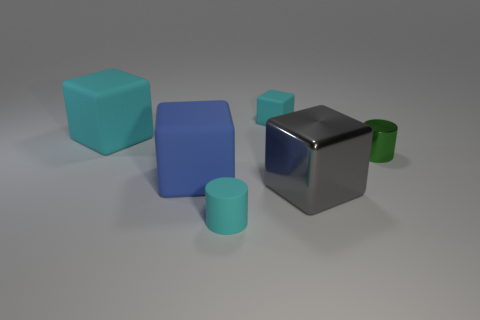Add 1 cyan matte blocks. How many objects exist? 7 Subtract all yellow cylinders. Subtract all red blocks. How many cylinders are left? 2 Subtract all red cubes. How many blue cylinders are left? 0 Subtract all tiny green shiny things. Subtract all matte cylinders. How many objects are left? 4 Add 3 blue things. How many blue things are left? 4 Add 3 blue matte cubes. How many blue matte cubes exist? 4 Subtract all blue cubes. How many cubes are left? 3 Subtract all tiny rubber blocks. How many blocks are left? 3 Subtract 0 yellow spheres. How many objects are left? 6 Subtract all cylinders. How many objects are left? 4 